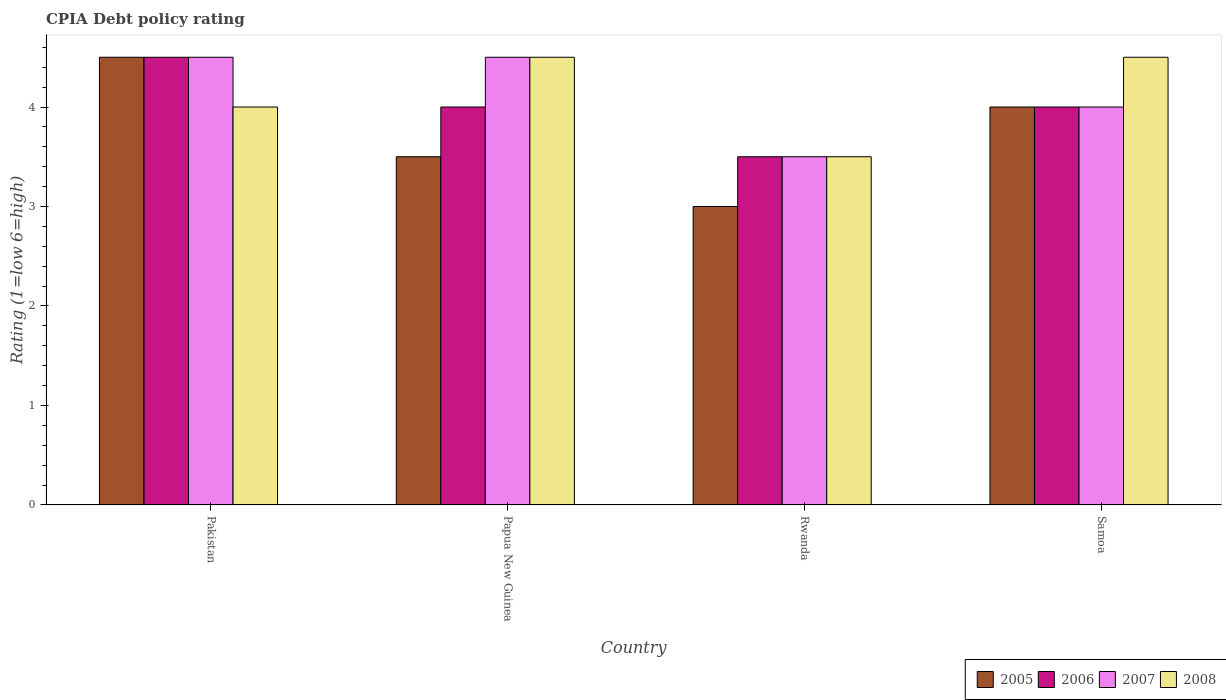What is the label of the 3rd group of bars from the left?
Your answer should be very brief. Rwanda. What is the CPIA rating in 2007 in Papua New Guinea?
Provide a short and direct response. 4.5. Across all countries, what is the maximum CPIA rating in 2008?
Make the answer very short. 4.5. In which country was the CPIA rating in 2008 maximum?
Keep it short and to the point. Papua New Guinea. In which country was the CPIA rating in 2007 minimum?
Your answer should be very brief. Rwanda. What is the difference between the CPIA rating in 2005 in Pakistan and the CPIA rating in 2007 in Papua New Guinea?
Your response must be concise. 0. What is the average CPIA rating in 2005 per country?
Your response must be concise. 3.75. What is the ratio of the CPIA rating in 2006 in Rwanda to that in Samoa?
Keep it short and to the point. 0.88. Is the CPIA rating in 2006 in Rwanda less than that in Samoa?
Ensure brevity in your answer.  Yes. What is the difference between the highest and the second highest CPIA rating in 2007?
Your answer should be compact. 0.5. What is the difference between the highest and the lowest CPIA rating in 2008?
Offer a terse response. 1. In how many countries, is the CPIA rating in 2005 greater than the average CPIA rating in 2005 taken over all countries?
Keep it short and to the point. 2. Is the sum of the CPIA rating in 2005 in Pakistan and Rwanda greater than the maximum CPIA rating in 2007 across all countries?
Ensure brevity in your answer.  Yes. Is it the case that in every country, the sum of the CPIA rating in 2007 and CPIA rating in 2006 is greater than the sum of CPIA rating in 2008 and CPIA rating in 2005?
Offer a terse response. No. Is it the case that in every country, the sum of the CPIA rating in 2006 and CPIA rating in 2005 is greater than the CPIA rating in 2008?
Keep it short and to the point. Yes. Are all the bars in the graph horizontal?
Make the answer very short. No. How many countries are there in the graph?
Your answer should be compact. 4. Are the values on the major ticks of Y-axis written in scientific E-notation?
Offer a very short reply. No. Does the graph contain any zero values?
Keep it short and to the point. No. Does the graph contain grids?
Give a very brief answer. No. Where does the legend appear in the graph?
Your answer should be very brief. Bottom right. How many legend labels are there?
Offer a terse response. 4. What is the title of the graph?
Your answer should be compact. CPIA Debt policy rating. Does "1995" appear as one of the legend labels in the graph?
Offer a very short reply. No. What is the label or title of the X-axis?
Provide a succinct answer. Country. What is the Rating (1=low 6=high) in 2006 in Papua New Guinea?
Provide a succinct answer. 4. What is the Rating (1=low 6=high) in 2007 in Papua New Guinea?
Give a very brief answer. 4.5. What is the Rating (1=low 6=high) in 2005 in Rwanda?
Ensure brevity in your answer.  3. What is the Rating (1=low 6=high) in 2008 in Rwanda?
Your answer should be very brief. 3.5. What is the Rating (1=low 6=high) of 2005 in Samoa?
Keep it short and to the point. 4. What is the Rating (1=low 6=high) of 2006 in Samoa?
Provide a short and direct response. 4. What is the Rating (1=low 6=high) in 2008 in Samoa?
Your response must be concise. 4.5. Across all countries, what is the maximum Rating (1=low 6=high) in 2005?
Ensure brevity in your answer.  4.5. Across all countries, what is the maximum Rating (1=low 6=high) of 2006?
Give a very brief answer. 4.5. Across all countries, what is the maximum Rating (1=low 6=high) in 2007?
Make the answer very short. 4.5. Across all countries, what is the minimum Rating (1=low 6=high) in 2006?
Provide a short and direct response. 3.5. Across all countries, what is the minimum Rating (1=low 6=high) in 2008?
Your response must be concise. 3.5. What is the total Rating (1=low 6=high) of 2005 in the graph?
Offer a very short reply. 15. What is the total Rating (1=low 6=high) of 2007 in the graph?
Ensure brevity in your answer.  16.5. What is the total Rating (1=low 6=high) of 2008 in the graph?
Offer a terse response. 16.5. What is the difference between the Rating (1=low 6=high) in 2005 in Pakistan and that in Papua New Guinea?
Make the answer very short. 1. What is the difference between the Rating (1=low 6=high) in 2006 in Pakistan and that in Papua New Guinea?
Your response must be concise. 0.5. What is the difference between the Rating (1=low 6=high) in 2007 in Pakistan and that in Papua New Guinea?
Make the answer very short. 0. What is the difference between the Rating (1=low 6=high) in 2008 in Pakistan and that in Papua New Guinea?
Your answer should be very brief. -0.5. What is the difference between the Rating (1=low 6=high) of 2005 in Pakistan and that in Rwanda?
Your answer should be very brief. 1.5. What is the difference between the Rating (1=low 6=high) in 2006 in Pakistan and that in Rwanda?
Keep it short and to the point. 1. What is the difference between the Rating (1=low 6=high) in 2008 in Pakistan and that in Rwanda?
Give a very brief answer. 0.5. What is the difference between the Rating (1=low 6=high) in 2005 in Pakistan and that in Samoa?
Ensure brevity in your answer.  0.5. What is the difference between the Rating (1=low 6=high) of 2007 in Pakistan and that in Samoa?
Your answer should be very brief. 0.5. What is the difference between the Rating (1=low 6=high) of 2008 in Pakistan and that in Samoa?
Your response must be concise. -0.5. What is the difference between the Rating (1=low 6=high) of 2005 in Papua New Guinea and that in Rwanda?
Give a very brief answer. 0.5. What is the difference between the Rating (1=low 6=high) in 2005 in Papua New Guinea and that in Samoa?
Offer a very short reply. -0.5. What is the difference between the Rating (1=low 6=high) of 2005 in Rwanda and that in Samoa?
Provide a short and direct response. -1. What is the difference between the Rating (1=low 6=high) of 2006 in Rwanda and that in Samoa?
Ensure brevity in your answer.  -0.5. What is the difference between the Rating (1=low 6=high) of 2008 in Rwanda and that in Samoa?
Ensure brevity in your answer.  -1. What is the difference between the Rating (1=low 6=high) of 2005 in Pakistan and the Rating (1=low 6=high) of 2007 in Papua New Guinea?
Offer a very short reply. 0. What is the difference between the Rating (1=low 6=high) of 2006 in Pakistan and the Rating (1=low 6=high) of 2008 in Papua New Guinea?
Your answer should be very brief. 0. What is the difference between the Rating (1=low 6=high) in 2007 in Pakistan and the Rating (1=low 6=high) in 2008 in Papua New Guinea?
Your answer should be very brief. 0. What is the difference between the Rating (1=low 6=high) in 2005 in Pakistan and the Rating (1=low 6=high) in 2006 in Rwanda?
Your answer should be very brief. 1. What is the difference between the Rating (1=low 6=high) of 2005 in Pakistan and the Rating (1=low 6=high) of 2007 in Rwanda?
Your answer should be very brief. 1. What is the difference between the Rating (1=low 6=high) in 2005 in Pakistan and the Rating (1=low 6=high) in 2008 in Rwanda?
Make the answer very short. 1. What is the difference between the Rating (1=low 6=high) in 2006 in Pakistan and the Rating (1=low 6=high) in 2007 in Rwanda?
Your answer should be compact. 1. What is the difference between the Rating (1=low 6=high) of 2006 in Pakistan and the Rating (1=low 6=high) of 2008 in Rwanda?
Offer a very short reply. 1. What is the difference between the Rating (1=low 6=high) in 2007 in Pakistan and the Rating (1=low 6=high) in 2008 in Rwanda?
Offer a very short reply. 1. What is the difference between the Rating (1=low 6=high) of 2005 in Pakistan and the Rating (1=low 6=high) of 2006 in Samoa?
Your answer should be very brief. 0.5. What is the difference between the Rating (1=low 6=high) in 2005 in Pakistan and the Rating (1=low 6=high) in 2007 in Samoa?
Your response must be concise. 0.5. What is the difference between the Rating (1=low 6=high) of 2006 in Pakistan and the Rating (1=low 6=high) of 2007 in Samoa?
Offer a terse response. 0.5. What is the difference between the Rating (1=low 6=high) of 2007 in Pakistan and the Rating (1=low 6=high) of 2008 in Samoa?
Ensure brevity in your answer.  0. What is the difference between the Rating (1=low 6=high) in 2005 in Papua New Guinea and the Rating (1=low 6=high) in 2008 in Rwanda?
Provide a succinct answer. 0. What is the difference between the Rating (1=low 6=high) of 2006 in Papua New Guinea and the Rating (1=low 6=high) of 2008 in Rwanda?
Provide a succinct answer. 0.5. What is the difference between the Rating (1=low 6=high) of 2005 in Papua New Guinea and the Rating (1=low 6=high) of 2007 in Samoa?
Your answer should be very brief. -0.5. What is the difference between the Rating (1=low 6=high) in 2006 in Papua New Guinea and the Rating (1=low 6=high) in 2007 in Samoa?
Keep it short and to the point. 0. What is the difference between the Rating (1=low 6=high) in 2006 in Papua New Guinea and the Rating (1=low 6=high) in 2008 in Samoa?
Your answer should be very brief. -0.5. What is the difference between the Rating (1=low 6=high) in 2005 in Rwanda and the Rating (1=low 6=high) in 2007 in Samoa?
Your answer should be very brief. -1. What is the difference between the Rating (1=low 6=high) in 2005 in Rwanda and the Rating (1=low 6=high) in 2008 in Samoa?
Ensure brevity in your answer.  -1.5. What is the difference between the Rating (1=low 6=high) in 2007 in Rwanda and the Rating (1=low 6=high) in 2008 in Samoa?
Your answer should be compact. -1. What is the average Rating (1=low 6=high) of 2005 per country?
Ensure brevity in your answer.  3.75. What is the average Rating (1=low 6=high) in 2007 per country?
Your answer should be very brief. 4.12. What is the average Rating (1=low 6=high) in 2008 per country?
Make the answer very short. 4.12. What is the difference between the Rating (1=low 6=high) of 2005 and Rating (1=low 6=high) of 2006 in Pakistan?
Provide a short and direct response. 0. What is the difference between the Rating (1=low 6=high) in 2005 and Rating (1=low 6=high) in 2008 in Pakistan?
Offer a terse response. 0.5. What is the difference between the Rating (1=low 6=high) of 2007 and Rating (1=low 6=high) of 2008 in Pakistan?
Your answer should be very brief. 0.5. What is the difference between the Rating (1=low 6=high) of 2005 and Rating (1=low 6=high) of 2007 in Papua New Guinea?
Offer a terse response. -1. What is the difference between the Rating (1=low 6=high) in 2006 and Rating (1=low 6=high) in 2007 in Papua New Guinea?
Ensure brevity in your answer.  -0.5. What is the difference between the Rating (1=low 6=high) in 2006 and Rating (1=low 6=high) in 2008 in Papua New Guinea?
Your answer should be compact. -0.5. What is the difference between the Rating (1=low 6=high) of 2005 and Rating (1=low 6=high) of 2008 in Rwanda?
Make the answer very short. -0.5. What is the difference between the Rating (1=low 6=high) of 2006 and Rating (1=low 6=high) of 2007 in Rwanda?
Offer a very short reply. 0. What is the difference between the Rating (1=low 6=high) in 2007 and Rating (1=low 6=high) in 2008 in Rwanda?
Provide a succinct answer. 0. What is the difference between the Rating (1=low 6=high) in 2005 and Rating (1=low 6=high) in 2007 in Samoa?
Make the answer very short. 0. What is the difference between the Rating (1=low 6=high) of 2006 and Rating (1=low 6=high) of 2007 in Samoa?
Your answer should be compact. 0. What is the ratio of the Rating (1=low 6=high) in 2007 in Pakistan to that in Papua New Guinea?
Provide a succinct answer. 1. What is the ratio of the Rating (1=low 6=high) in 2006 in Pakistan to that in Rwanda?
Make the answer very short. 1.29. What is the ratio of the Rating (1=low 6=high) of 2007 in Pakistan to that in Rwanda?
Give a very brief answer. 1.29. What is the ratio of the Rating (1=low 6=high) of 2005 in Pakistan to that in Samoa?
Offer a very short reply. 1.12. What is the ratio of the Rating (1=low 6=high) of 2007 in Pakistan to that in Samoa?
Provide a short and direct response. 1.12. What is the ratio of the Rating (1=low 6=high) in 2008 in Pakistan to that in Samoa?
Keep it short and to the point. 0.89. What is the ratio of the Rating (1=low 6=high) of 2005 in Papua New Guinea to that in Rwanda?
Your answer should be compact. 1.17. What is the ratio of the Rating (1=low 6=high) in 2006 in Papua New Guinea to that in Rwanda?
Give a very brief answer. 1.14. What is the ratio of the Rating (1=low 6=high) of 2008 in Papua New Guinea to that in Rwanda?
Ensure brevity in your answer.  1.29. What is the ratio of the Rating (1=low 6=high) in 2008 in Papua New Guinea to that in Samoa?
Keep it short and to the point. 1. What is the difference between the highest and the second highest Rating (1=low 6=high) in 2007?
Ensure brevity in your answer.  0. What is the difference between the highest and the lowest Rating (1=low 6=high) in 2005?
Make the answer very short. 1.5. What is the difference between the highest and the lowest Rating (1=low 6=high) in 2008?
Give a very brief answer. 1. 